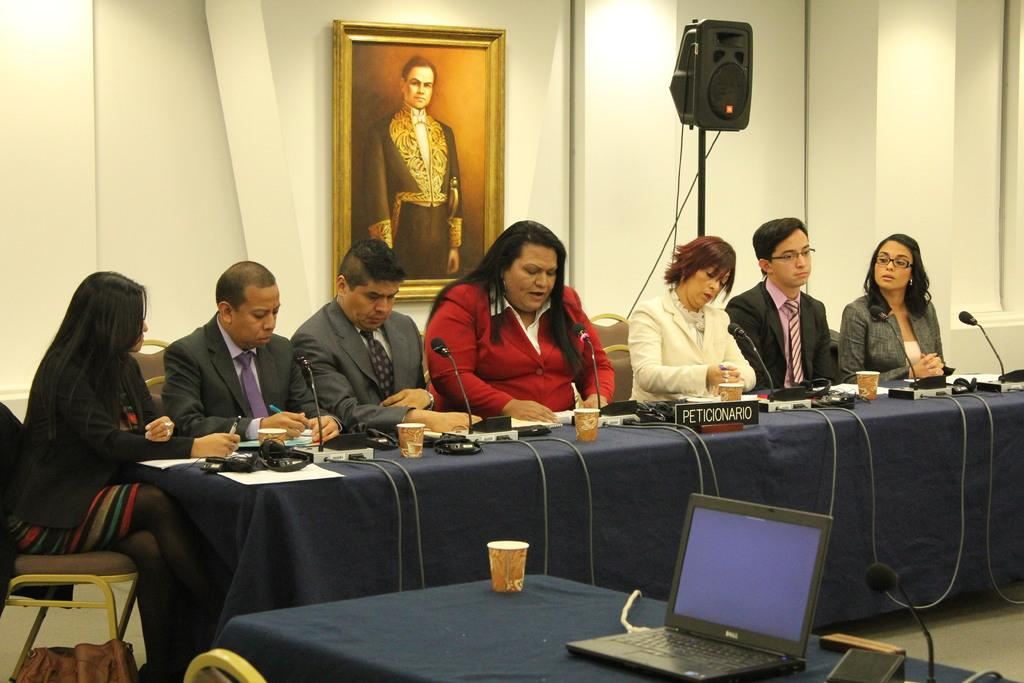<image>
Present a compact description of the photo's key features. a council member panel with ms. peticiorio as leader 